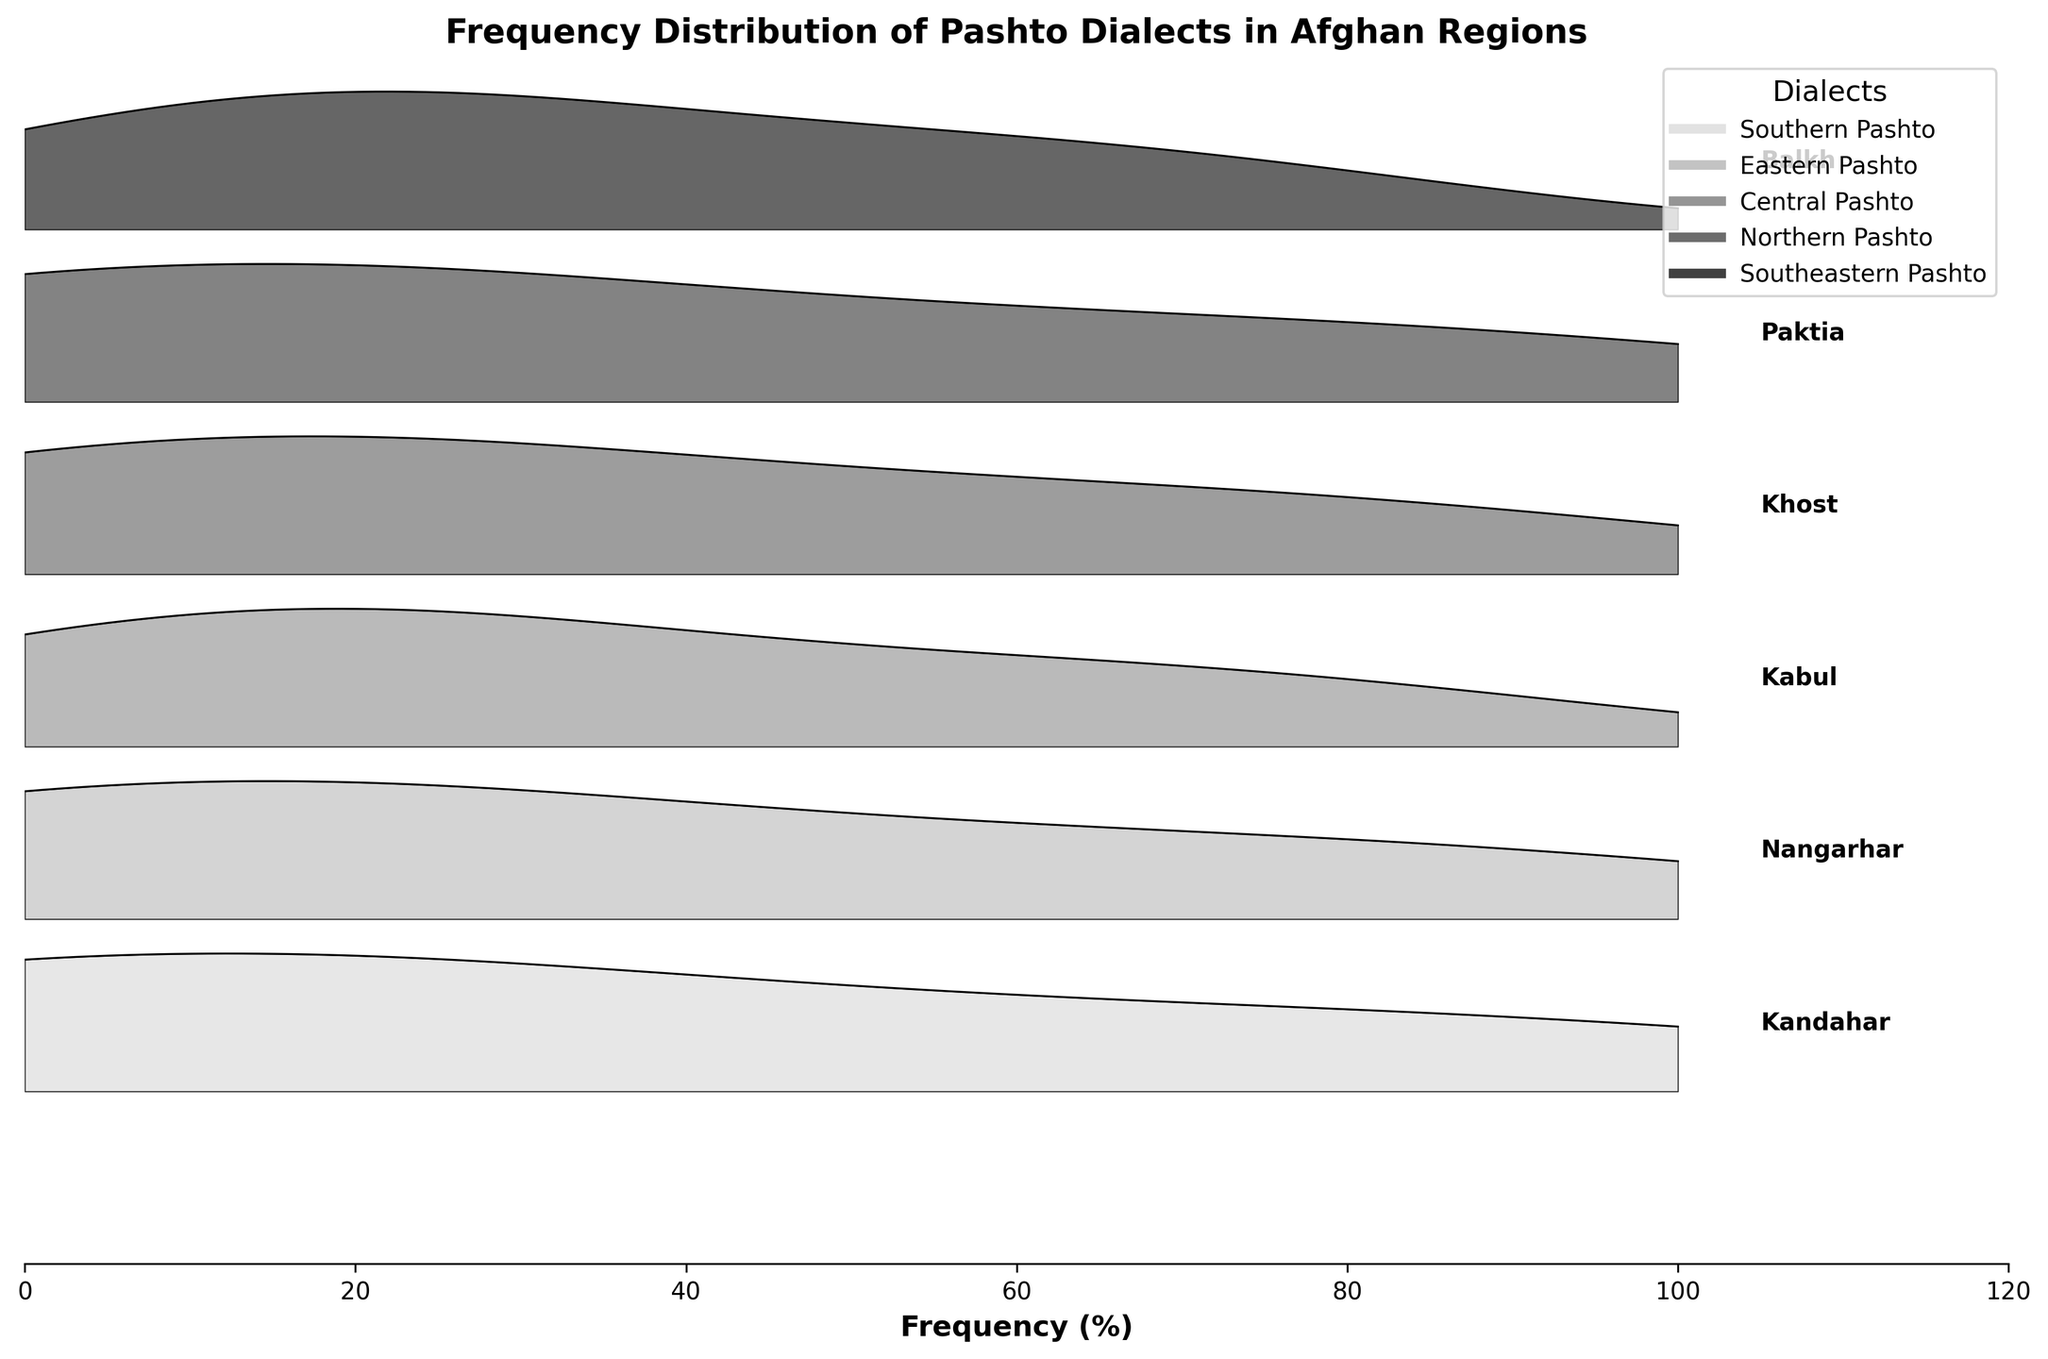Which region has the highest frequency of Southern Pashto speakers? By examining the plot, look for the peak closest to 85% frequency for Southern Pashto associated with a region label. The region label at this peak is "Kandahar."
Answer: Kandahar Which region shows the smallest frequency for Northern Pashto? By scanning the ridgeline plot for Northern Pashto frequencies, the smallest bar or bump is associated with "Nangarhar" at 5%.
Answer: Nangarhar What is the total frequency of Central Pashto speakers in Kabul and Kandahar regions combined? From the plot, Central Pashto has frequencies of 70% in Kabul and 5% in Kandahar. Add these values: 70 + 5 = 75%.
Answer: 75% How does the frequency of Eastern Pashto in Khost compare to that in Nangarhar? Compare the heights of the ridges for Eastern Pashto in Khost (20%) and Nangarhar (80%). Khost has a lower frequency.
Answer: Less in Khost Which dialect in Paktia has the highest frequency and what is it? Paktia's ridgeplot shows the highest frequency peak for Southeastern Pashto at 80%.
Answer: Southeastern Pashto at 80% What are the frequencies of Southern Pashto across all regions? The plot shows Southern Pashto at 85% in Kandahar, 15% in Nangarhar, 10% in Kabul, 5% in Paktia, and 5% in Northern Pashto. Summarize these values.
Answer: 85, 15, 10, 5, 5 What's the median frequency of all listed dialects in Kabul? Listed frequencies in Kabul are Central Pashto (70), Eastern Pashto (20), Southern Pashto (10). Median: sort (10, 20, 70), and the middle value is 20.
Answer: 20 Which region has the broadest range (min to max) of dialect frequencies? Compare the range of frequencies (max - min) in each region: Kandahar (85 - 5), Nangarhar (80 - 5), Kabul (70 - 10), Khost (75 - 5), Paktia (80 - 5), Balkh (65 - 10). Kandahar has the range: 85 - 5 = 80%.
Answer: Kandahar What's the overall trend in the frequency of Central Pashto dialects across regions? Observe the plot and see that Central Pashto occupies moderate ranges overall, peaking at 70% in Kabul and being notable at 25% in Balkh. It’s more concentrated centrally.
Answer: Moderately concentrated, peaks in Kabul Which region shows a similar distribution pattern for two or more dialects? Observing regions with nearly synchronized peaks: compare Nangarhar's peaks for different dialects: Eastern Pashto (80%), Southern Pashto (15%), and Northern Pashto (5%) show a detuned similar pattern.
Answer: Nangarhar 